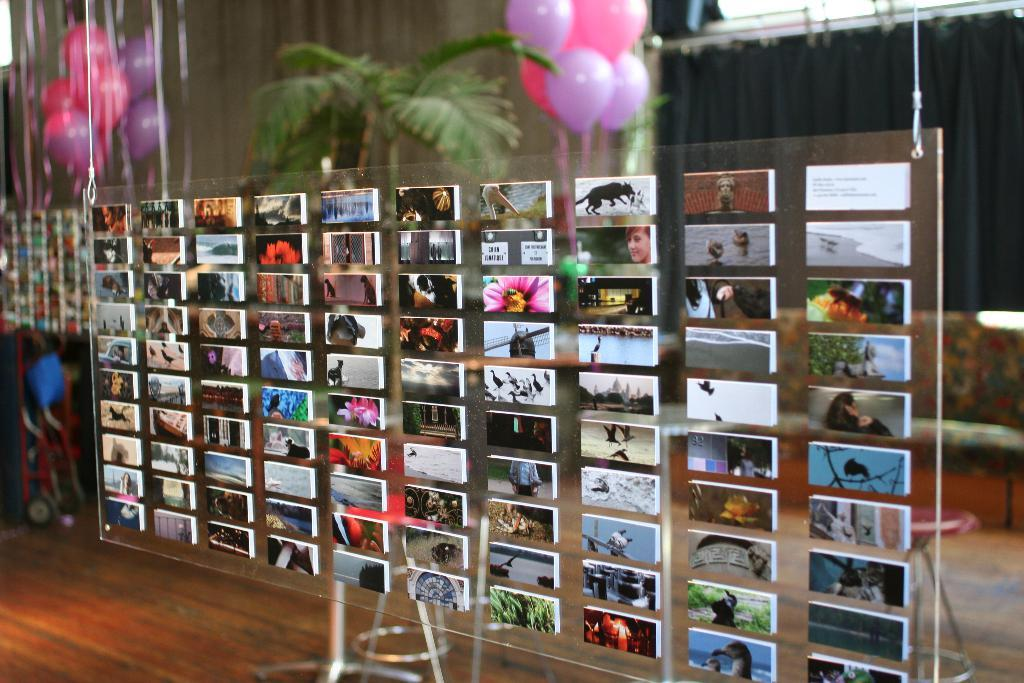What is attached to the glass surface in the image? There are photos attached to a glass surface in the image. What can be seen in the background of the image? There are trees visible in the background of the image. What additional objects are present in the image? There are balloons in the image. What word is written on the plate in the image? There is no plate present in the image, so no word can be written on it. 